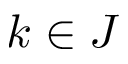Convert formula to latex. <formula><loc_0><loc_0><loc_500><loc_500>k \in J</formula> 